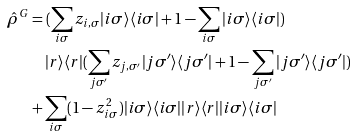Convert formula to latex. <formula><loc_0><loc_0><loc_500><loc_500>\hat { \rho } ^ { G } & = ( \sum _ { i \sigma } z _ { i , \sigma } | i \sigma \rangle \langle i \sigma | + 1 - \sum _ { i \sigma } | i \sigma \rangle \langle i \sigma | ) \\ & \quad | r \rangle \langle r | ( \sum _ { j \sigma ^ { \prime } } z _ { j , \sigma ^ { \prime } } | j \sigma ^ { \prime } \rangle \langle j \sigma ^ { \prime } | + 1 - \sum _ { j \sigma ^ { \prime } } | j \sigma ^ { \prime } \rangle \langle j \sigma ^ { \prime } | ) \\ & + \sum _ { i \sigma } ( 1 - z _ { i \sigma } ^ { 2 } ) | i \sigma \rangle \langle i \sigma | | r \rangle \langle r | | i \sigma \rangle \langle i \sigma |</formula> 